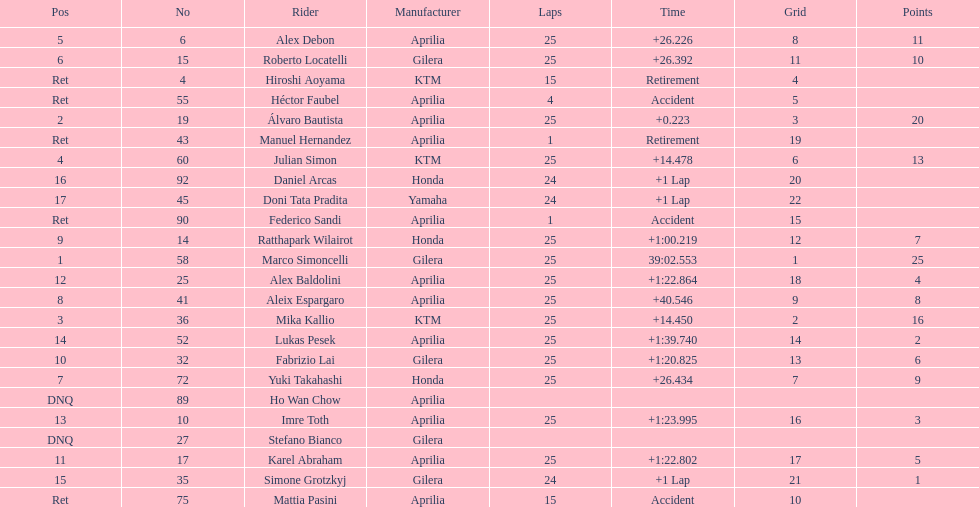The country with the most riders was Italy. 